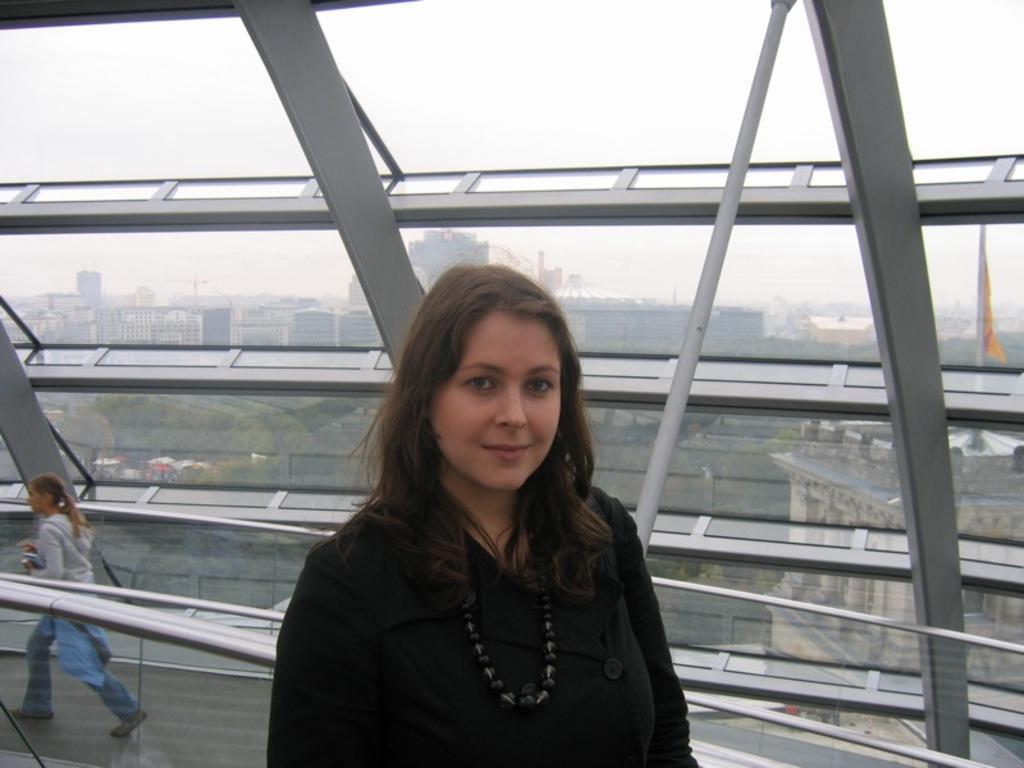Please provide a concise description of this image. In the center of the image, we can see a lady and in the background, there is an other person and we can see rods and glass, through the glass we can see buildings, trees and there is a flag. 